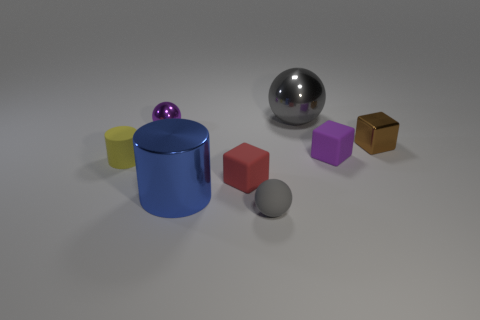Add 1 tiny yellow blocks. How many objects exist? 9 Subtract all spheres. How many objects are left? 5 Add 5 gray metal balls. How many gray metal balls are left? 6 Add 4 big metal cylinders. How many big metal cylinders exist? 5 Subtract 1 purple blocks. How many objects are left? 7 Subtract all tiny brown metallic cubes. Subtract all brown metallic things. How many objects are left? 6 